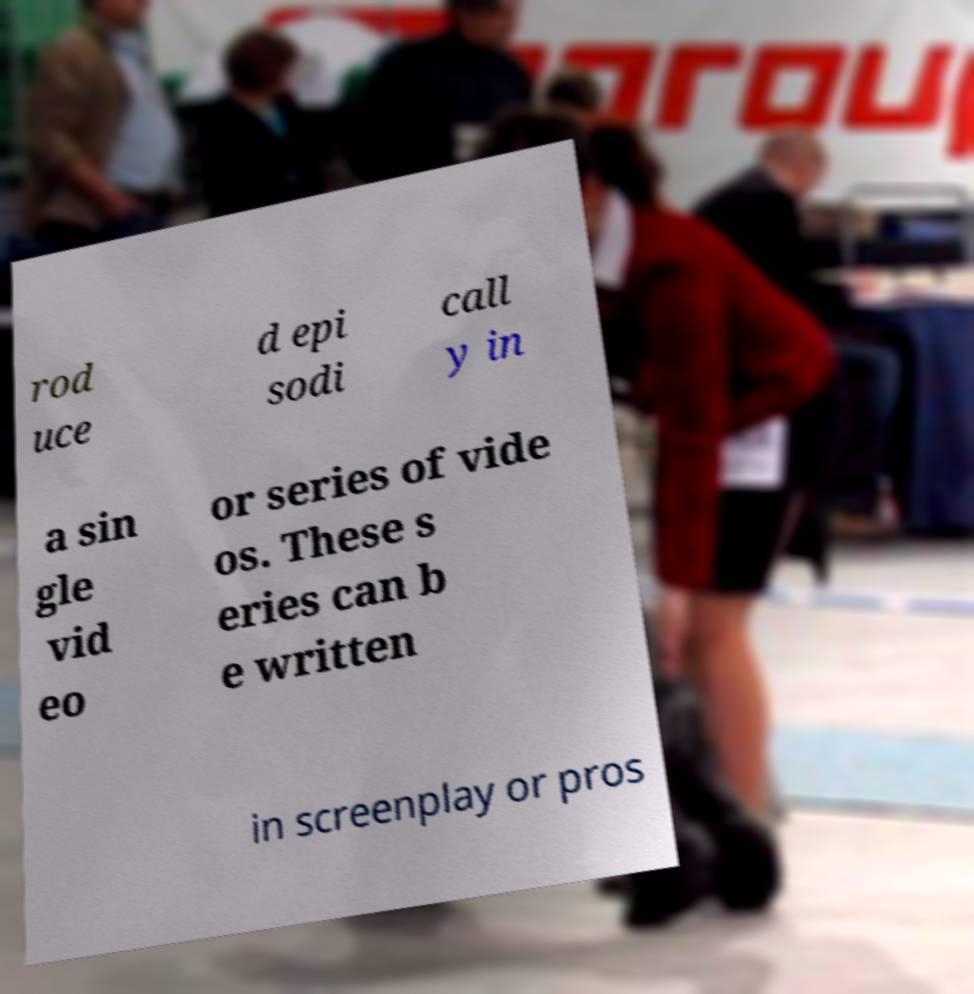Please identify and transcribe the text found in this image. rod uce d epi sodi call y in a sin gle vid eo or series of vide os. These s eries can b e written in screenplay or pros 